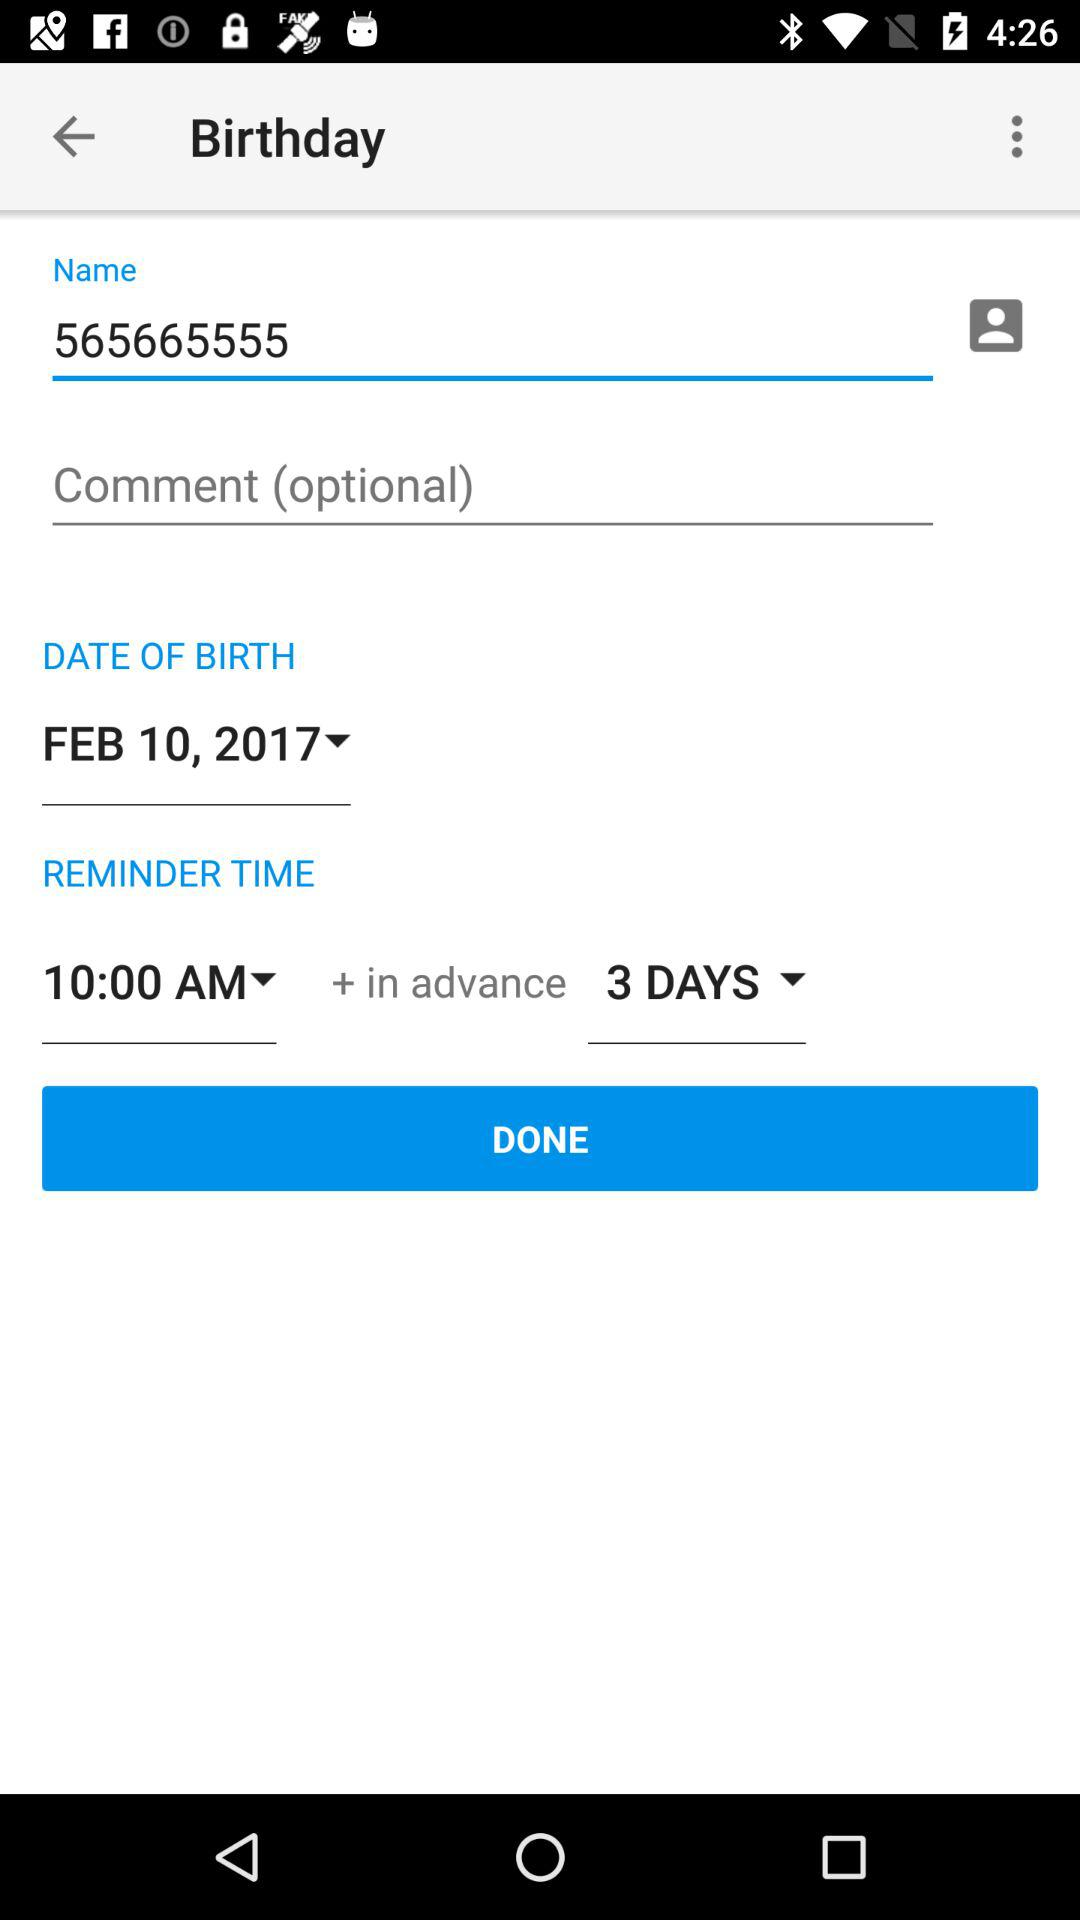What is the date of birth of the user? The date of birth of the user is February 10, 2017. 